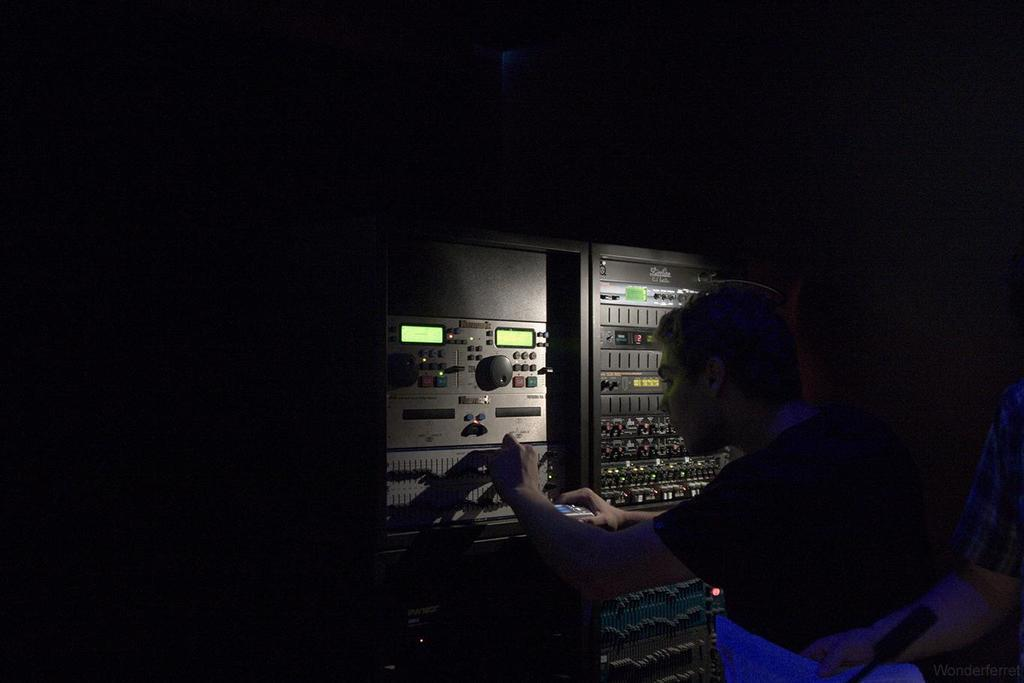Who is present in the image? There is a man in the image. What is the man doing in the image? The man is standing in front of an electrical machine. Where is the electrical machine located in the image? The electrical machine is on the right side of the image. What is the color of the background in the image? The background of the image is black. What type of soda is being poured into the electrical machine in the image? There is no soda present in the image, and the electrical machine is not being used for pouring any liquid. 